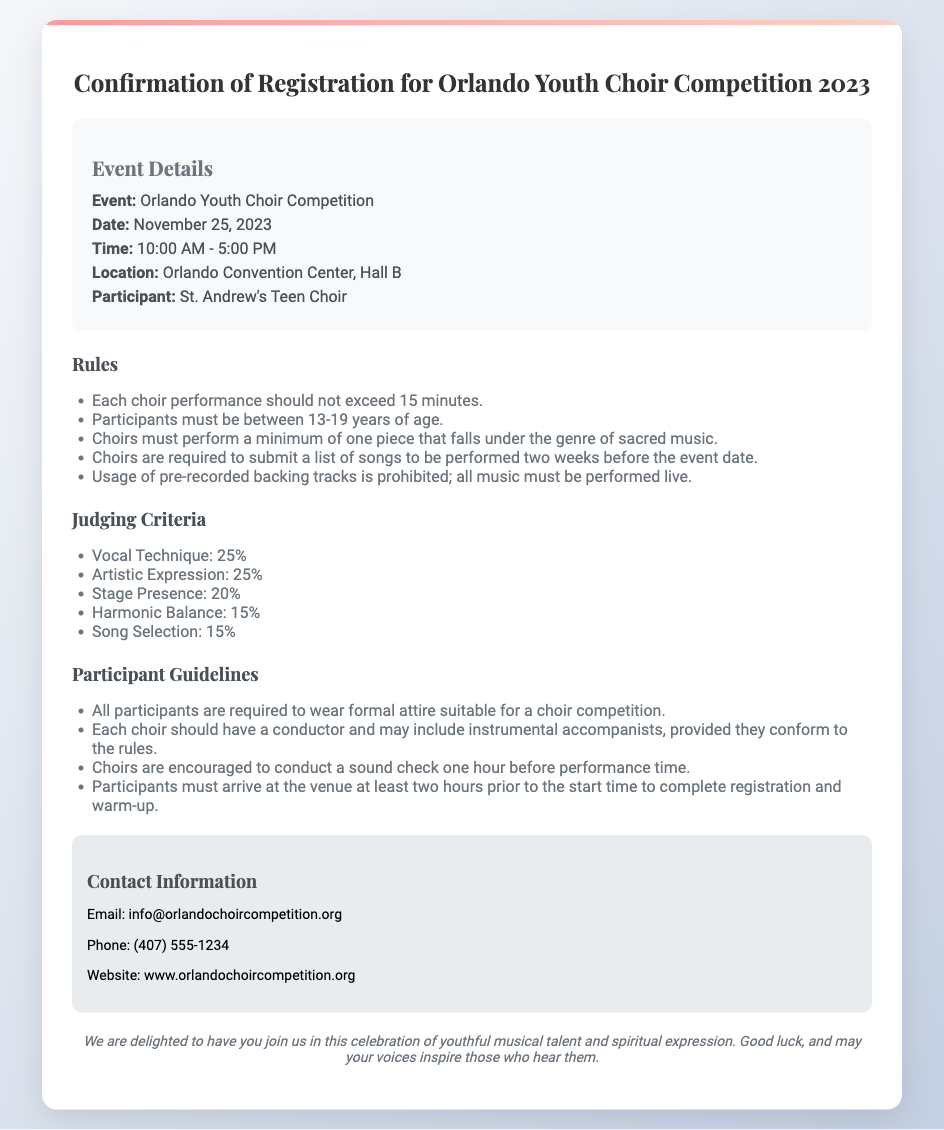What is the date of the event? The date of the event is explicitly stated in the document.
Answer: November 25, 2023 What is the location of the competition? The location of the competition is provided in the event details section.
Answer: Orlando Convention Center, Hall B What percentage of the judging criteria is allocated to Vocal Technique? The document outlines the judging criteria and their respective percentages.
Answer: 25% How many minutes can each choir performance last? The document specifies the maximum duration for choir performances.
Answer: 15 minutes What is the age range for participants? The document clearly outlines the age requirements for participants.
Answer: 13-19 years What type of music must each choir perform? The document specifies a requirement regarding the genre of one of the performance pieces.
Answer: Sacred music How long before the performance must participants arrive? The requirements for arrival time before the performance are detailed in the participant guidelines.
Answer: Two hours What attire must participants wear? The guidelines specify what participants should wear for the competition.
Answer: Formal attire What is the email contact for inquiries? The contact information provides a way to reach out for more details.
Answer: info@orlandochoircompetition.org 